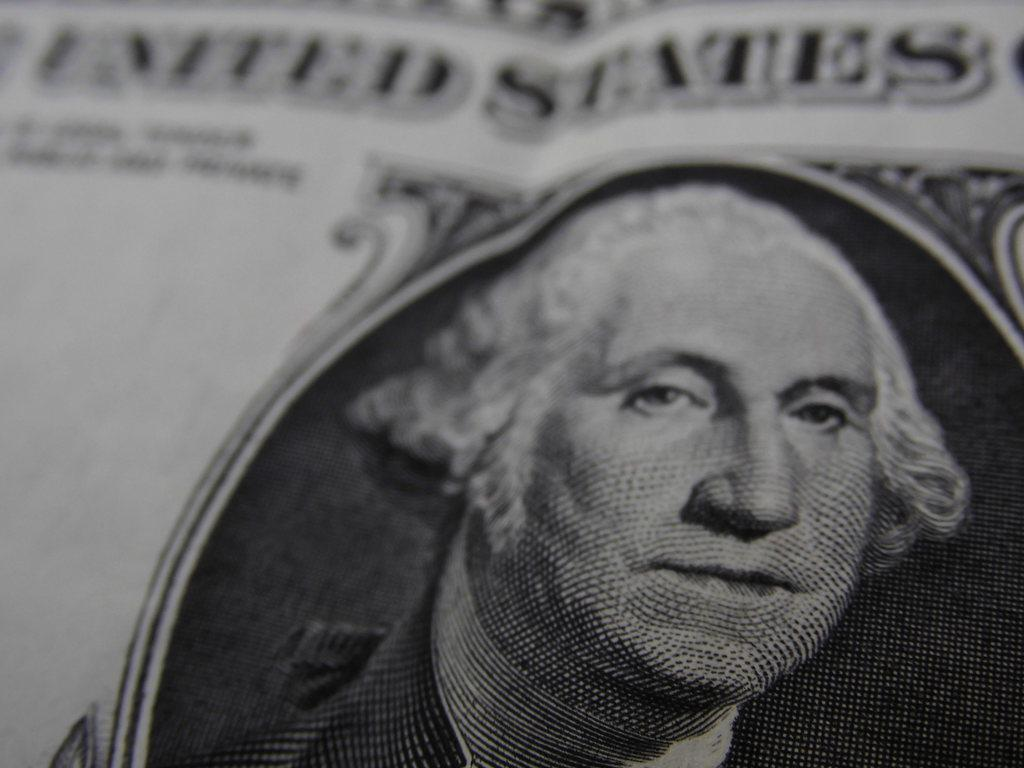What is the main object in the image? There is a newspaper in the image. What can be seen at the top of the newspaper? The newspaper has text at the top. Is there any visual element on the newspaper besides the text? Yes, there is an image of a person on the newspaper. What type of mint can be seen growing near the newspaper in the image? There is no mint or any plant life visible in the image; it only features a newspaper with text and an image of a person. 